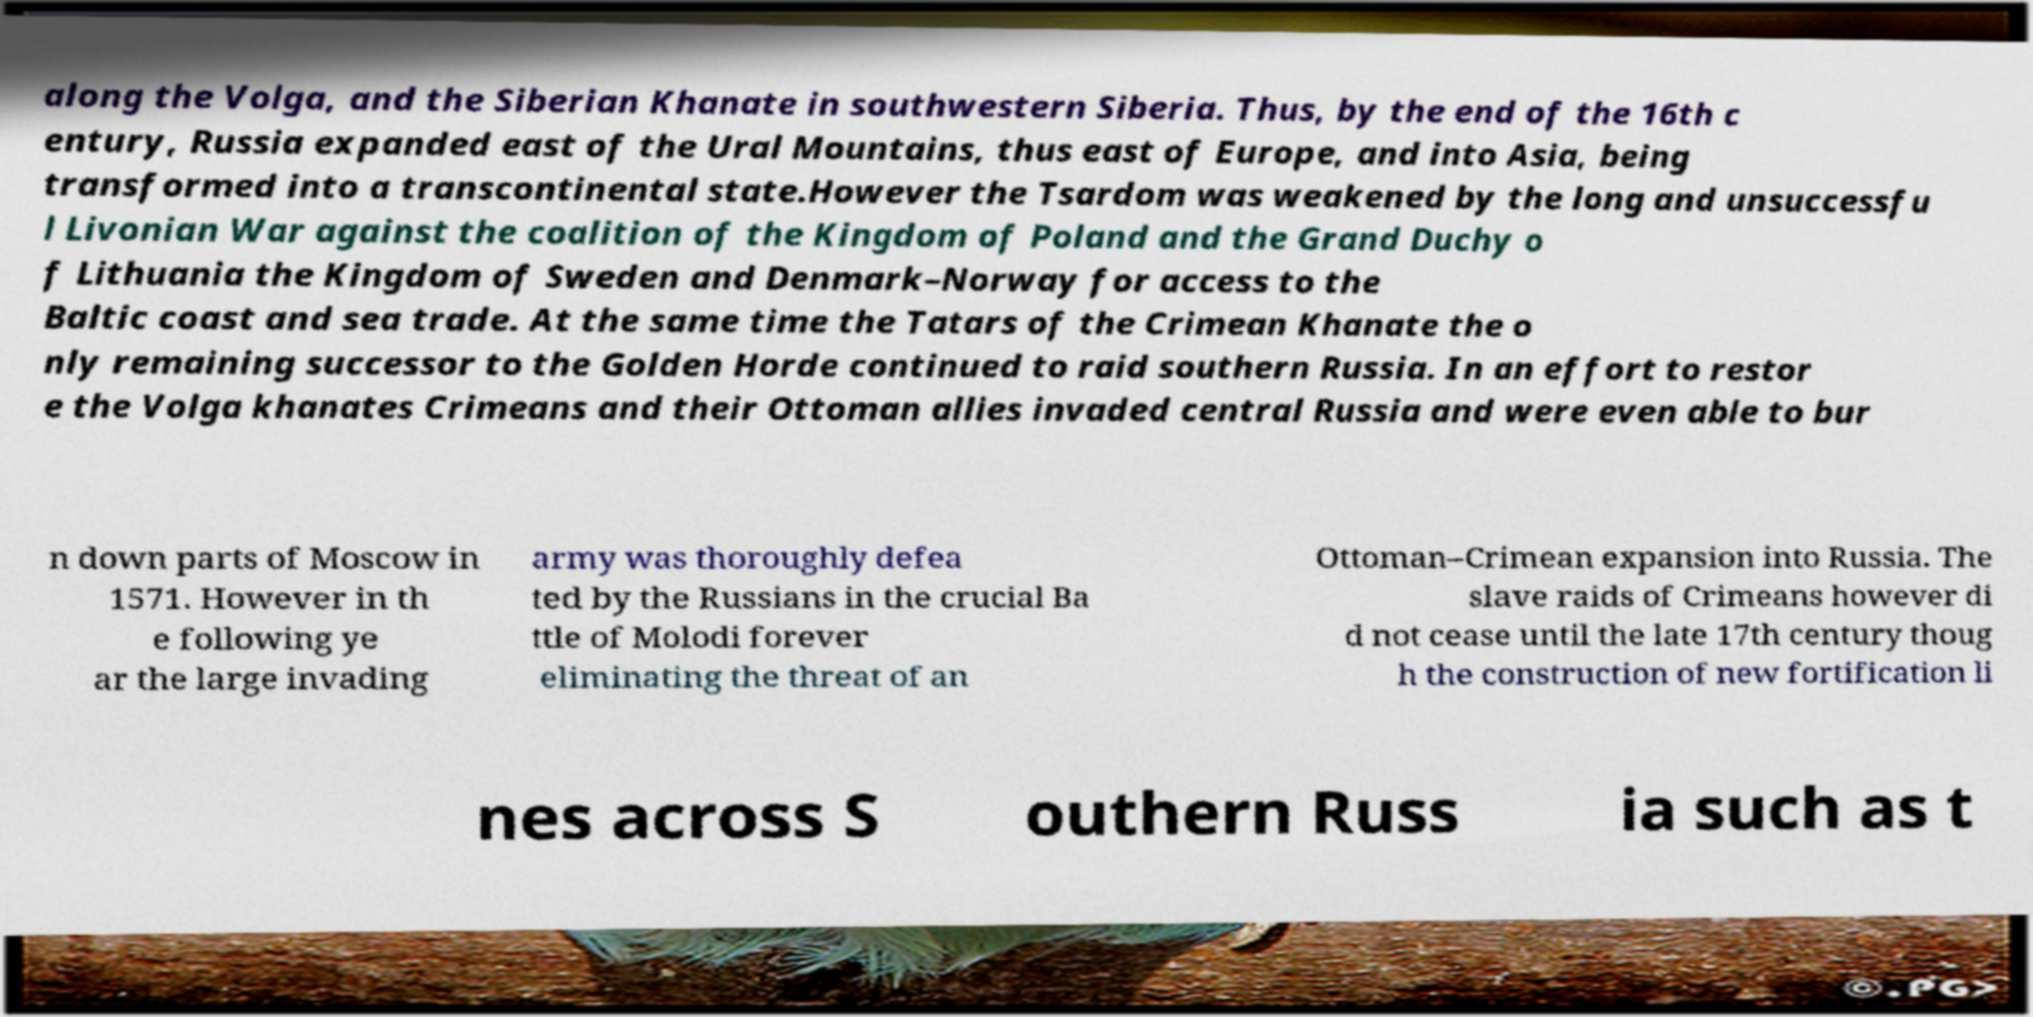For documentation purposes, I need the text within this image transcribed. Could you provide that? along the Volga, and the Siberian Khanate in southwestern Siberia. Thus, by the end of the 16th c entury, Russia expanded east of the Ural Mountains, thus east of Europe, and into Asia, being transformed into a transcontinental state.However the Tsardom was weakened by the long and unsuccessfu l Livonian War against the coalition of the Kingdom of Poland and the Grand Duchy o f Lithuania the Kingdom of Sweden and Denmark–Norway for access to the Baltic coast and sea trade. At the same time the Tatars of the Crimean Khanate the o nly remaining successor to the Golden Horde continued to raid southern Russia. In an effort to restor e the Volga khanates Crimeans and their Ottoman allies invaded central Russia and were even able to bur n down parts of Moscow in 1571. However in th e following ye ar the large invading army was thoroughly defea ted by the Russians in the crucial Ba ttle of Molodi forever eliminating the threat of an Ottoman–Crimean expansion into Russia. The slave raids of Crimeans however di d not cease until the late 17th century thoug h the construction of new fortification li nes across S outhern Russ ia such as t 